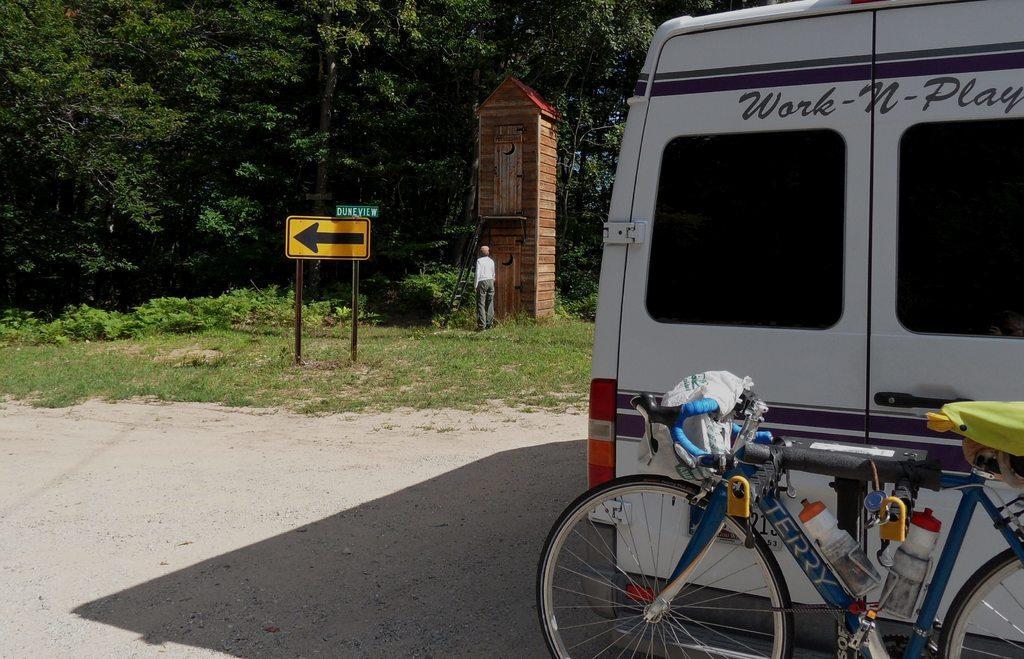In one or two sentences, can you explain what this image depicts? In this image we can see a vehicle with a bicycle parked on the road. In the background there is a direction board, a small wooden house with a ladder and also trees. We can also see a person standing on the grass. 